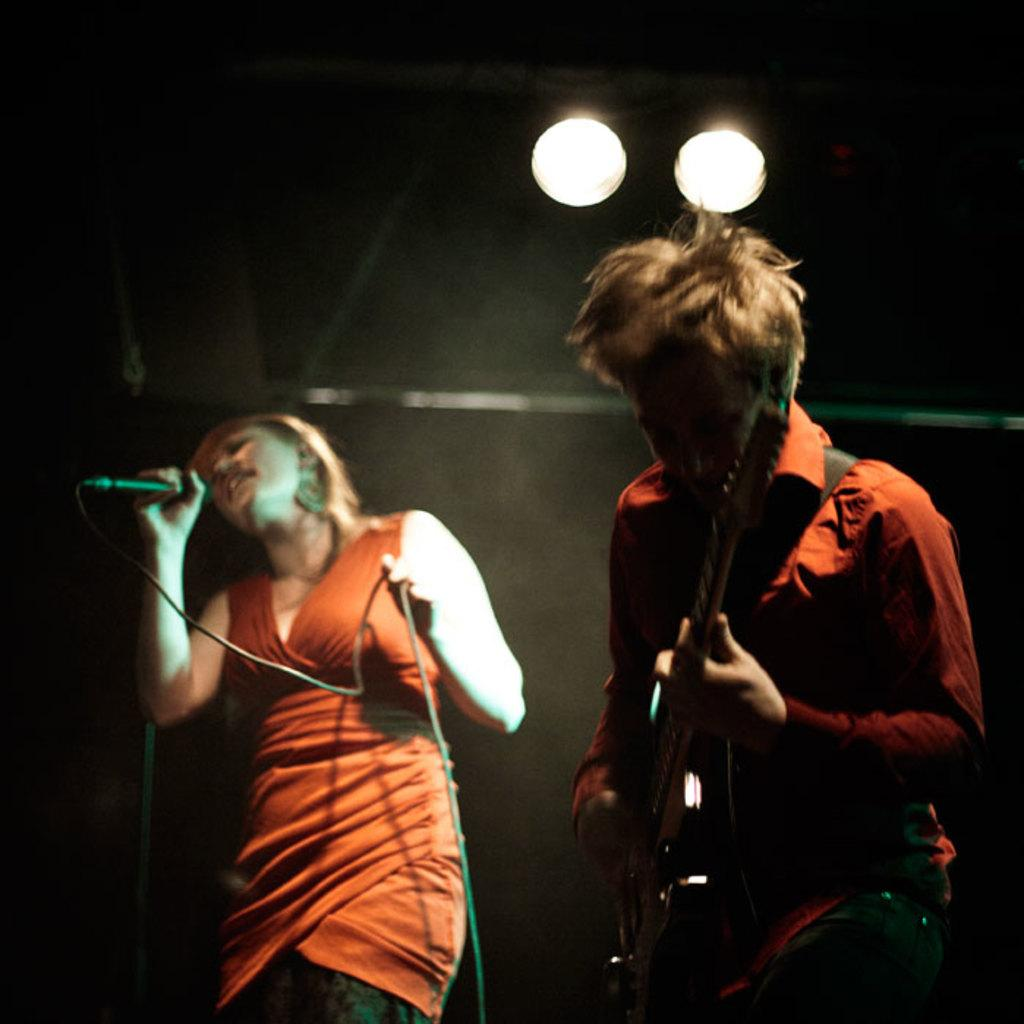What is the woman in the image doing? The woman is singing into a microphone. What is the woman wearing in the image? The woman is wearing an orange dress. What is the man in the image doing? The man is playing a guitar. What is the man wearing in the image? The man is wearing an orange shirt. Can you see a dog playing with a vessel in the image? There is no dog or vessel present in the image. Is there a monkey performing a trick in the image? There is no monkey or trick present in the image. 